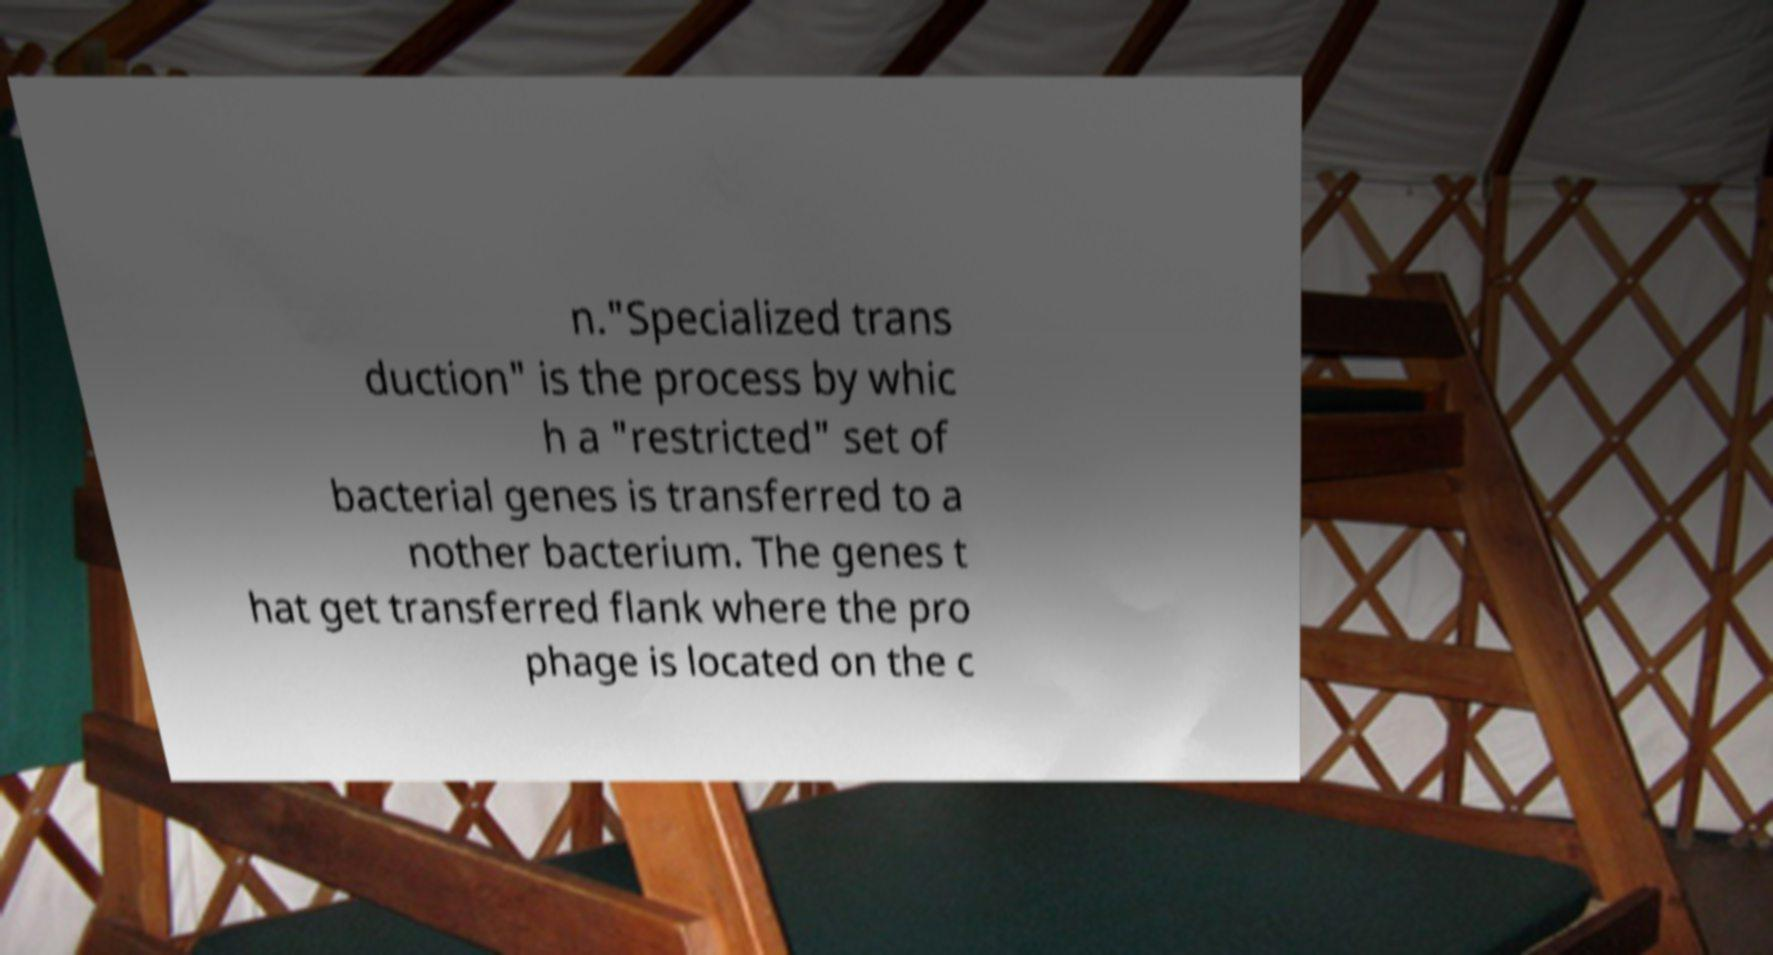Can you read and provide the text displayed in the image?This photo seems to have some interesting text. Can you extract and type it out for me? n."Specialized trans duction" is the process by whic h a "restricted" set of bacterial genes is transferred to a nother bacterium. The genes t hat get transferred flank where the pro phage is located on the c 